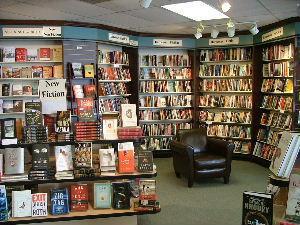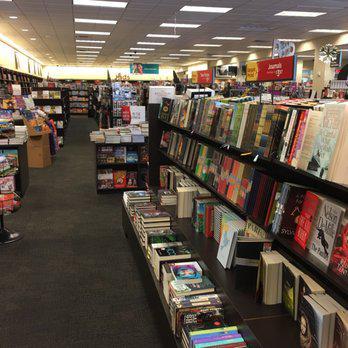The first image is the image on the left, the second image is the image on the right. Evaluate the accuracy of this statement regarding the images: "In at least one image there is a single long haired girl looking at book on a brown bookshelf.". Is it true? Answer yes or no. No. The first image is the image on the left, the second image is the image on the right. Given the left and right images, does the statement "There is one person in the bookstore looking at books in one of the images." hold true? Answer yes or no. No. 